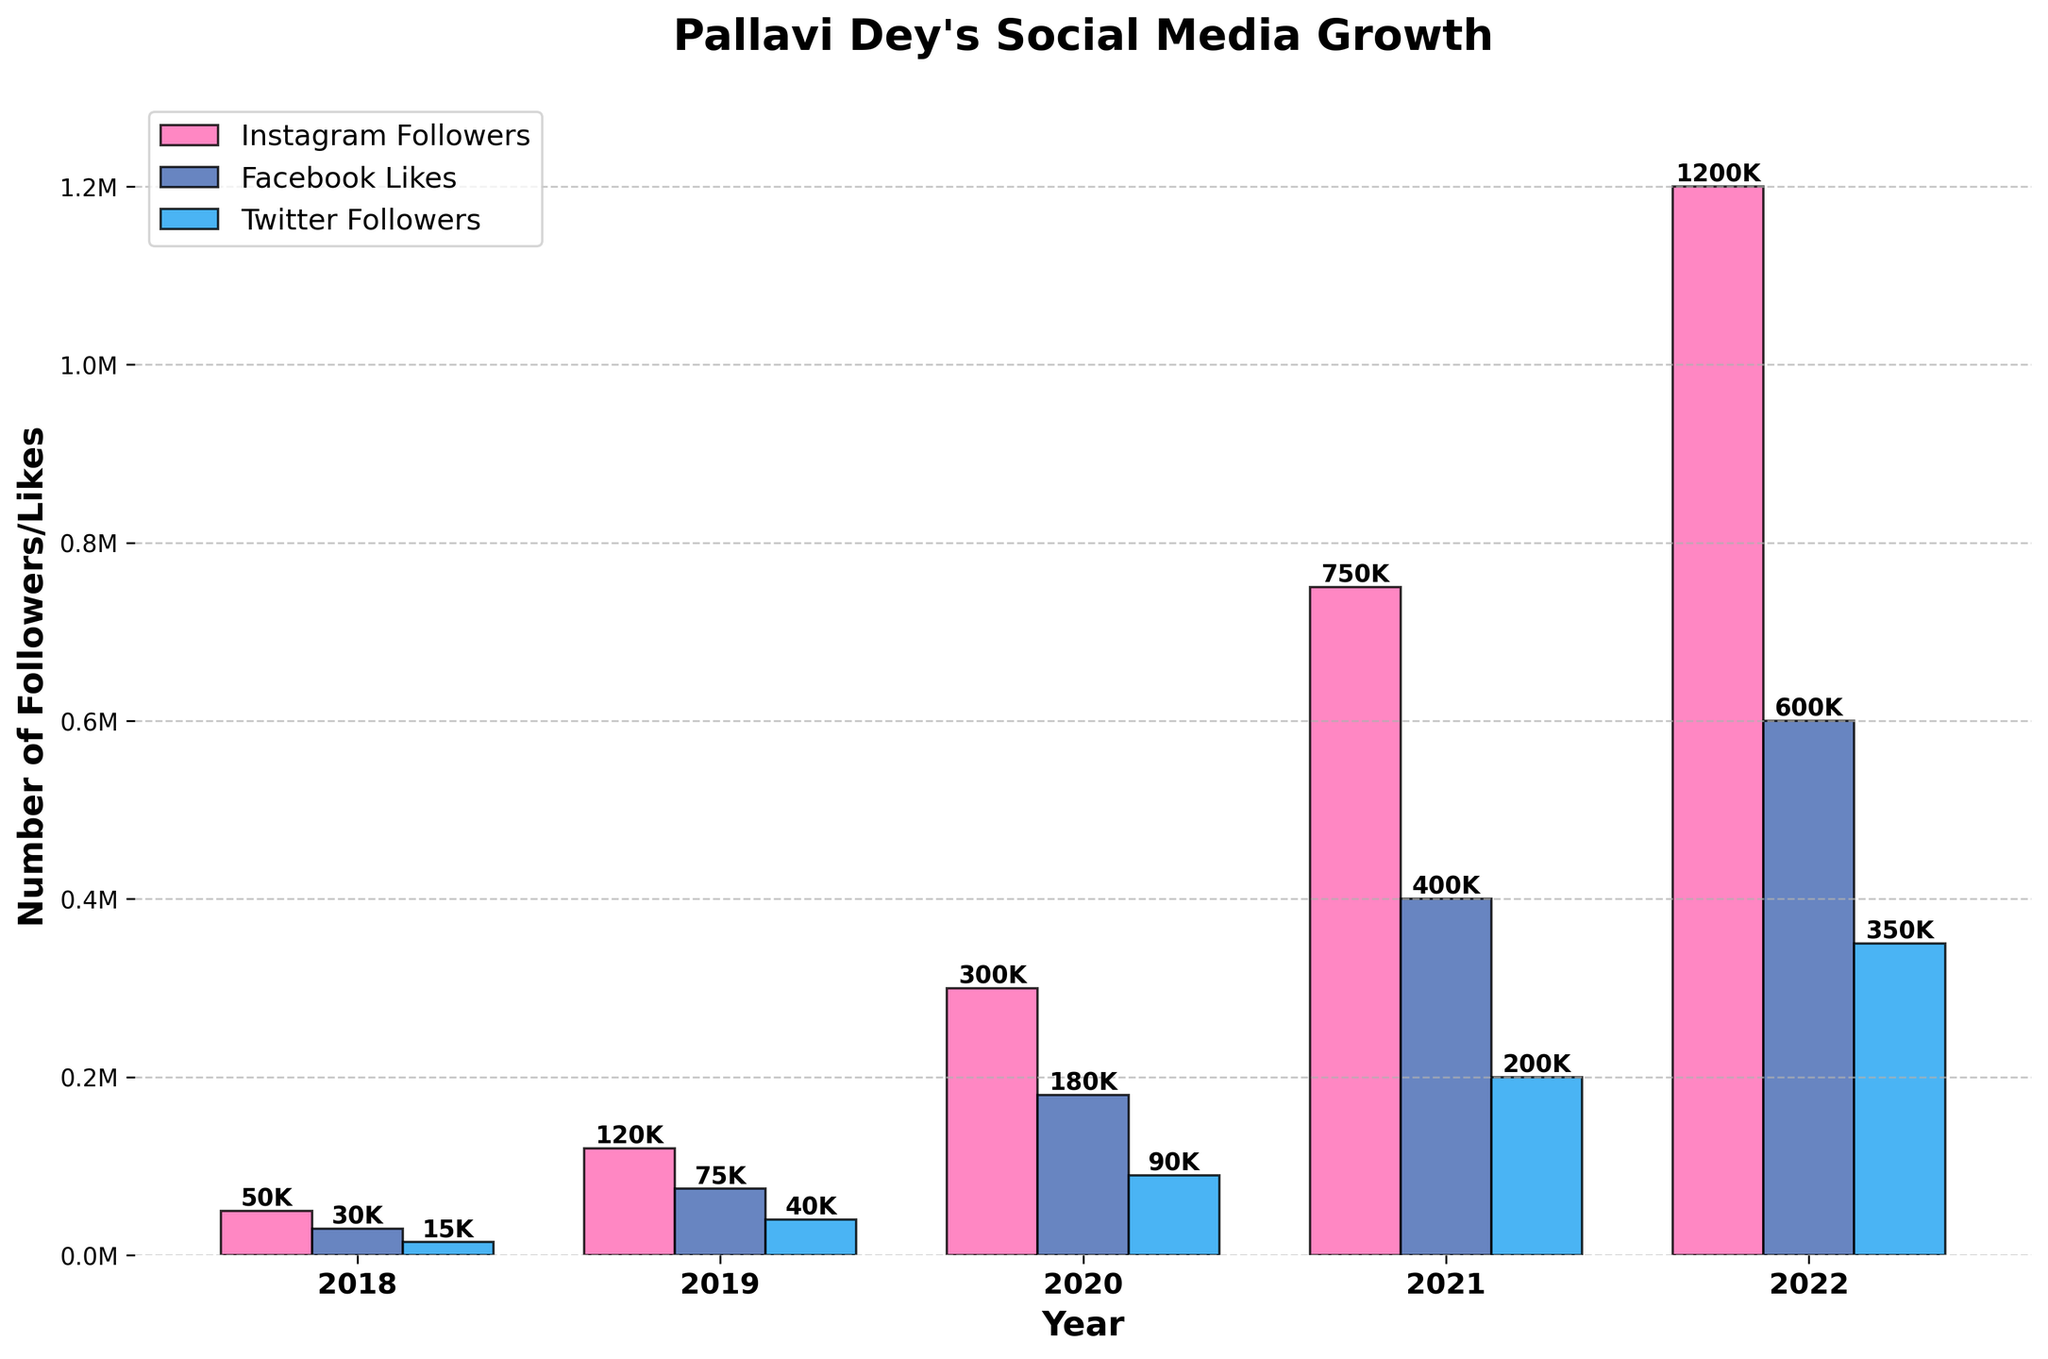How many Instagram followers did Pallavi Dey gain from 2018 to 2022? To find this, subtract Instagram followers in 2018 from 2022: 1200000 - 50000 = 1150000
Answer: 1150000 Which social media platform had the most significant growth in followers/likes from 2018 to 2022? To determine this, compare the increase for each platform: Instagram (1200000 - 50000), Facebook (600000 - 30000), and Twitter (350000 - 15000). Instagram had the highest growth.
Answer: Instagram In which year did Facebook likes see the largest increase compared to the previous year? Check the increments year-by-year: 2019 (75000 - 30000 = 45000), 2020 (180000 - 75000 = 105000), 2021 (400000 - 180000 = 220000), 2022 (600000 - 400000 = 200000). The largest increase is in 2021.
Answer: 2021 By how many followers did Twitter grow from 2019 to 2021? Subtract Twitter followers in 2019 from 2021: 200000 - 40000 = 160000
Answer: 160000 In which year did Instagram followers surpass the 1 million mark? Observing the figure, Instagram followers reached 1 million between 2021 (750000) and 2022 (1200000). Clearly, it was achieved in 2022.
Answer: 2022 Which year had the smallest relative increase in total social media followers for Pallavi Dey? Calculate the total followers/likes each year and find the smallest relative increase: 2018 (95000), 2019 (235000), 2020 (570000), 2021 (1350000), 2022 (2150000). The increases are (95000 to 235000 = 140000), (235000 to 570000 = 335000), (570000 to 1350000 = 780000), (1350000 to 2150000 = 800000). The smallest increase is from 2018 to 2019.
Answer: 2019 What is the average number of Facebook Likes per year from 2018 to 2022? Add the total Facebook likes and divide by 5: (30000 + 75000 + 180000 + 400000 + 600000) / 5 = 1285000 / 5 = 257000
Answer: 257000 Which social media platform had the smallest number of followers or likes in 2020? Comparing numbers in 2020: Instagram (300000), Facebook (180000), Twitter (90000). Twitter had the smallest number.
Answer: Twitter 